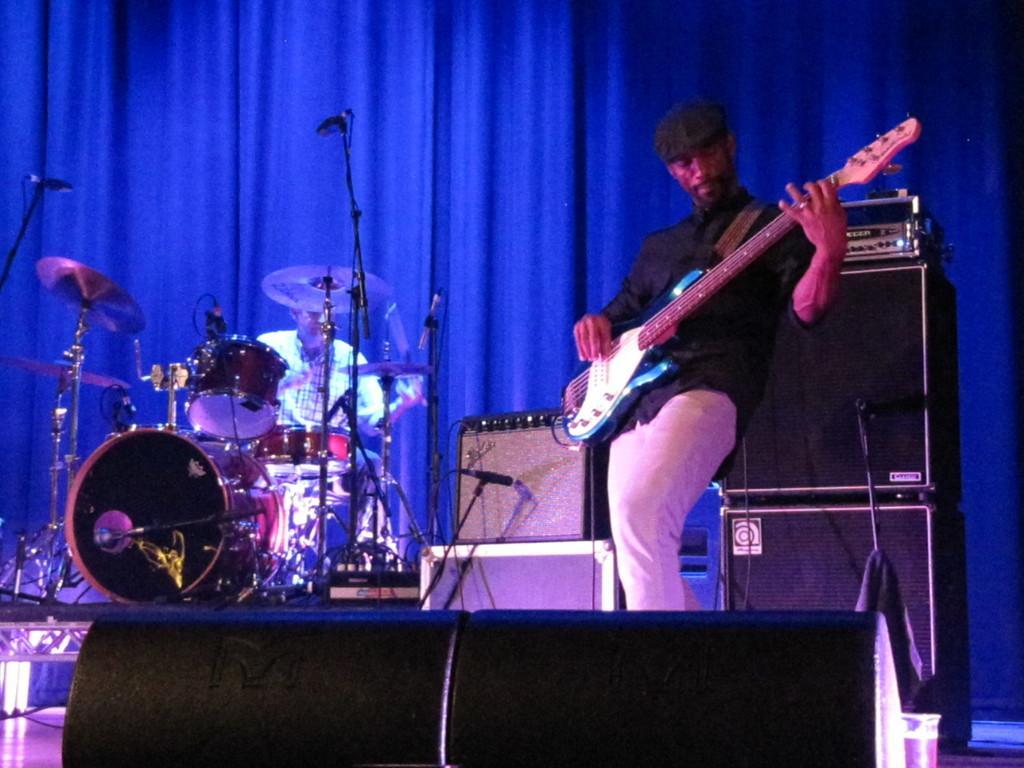Describe this image in one or two sentences. This picture shows a man playing guitar holding in his hand and we see a man seated and playing drums on the side 